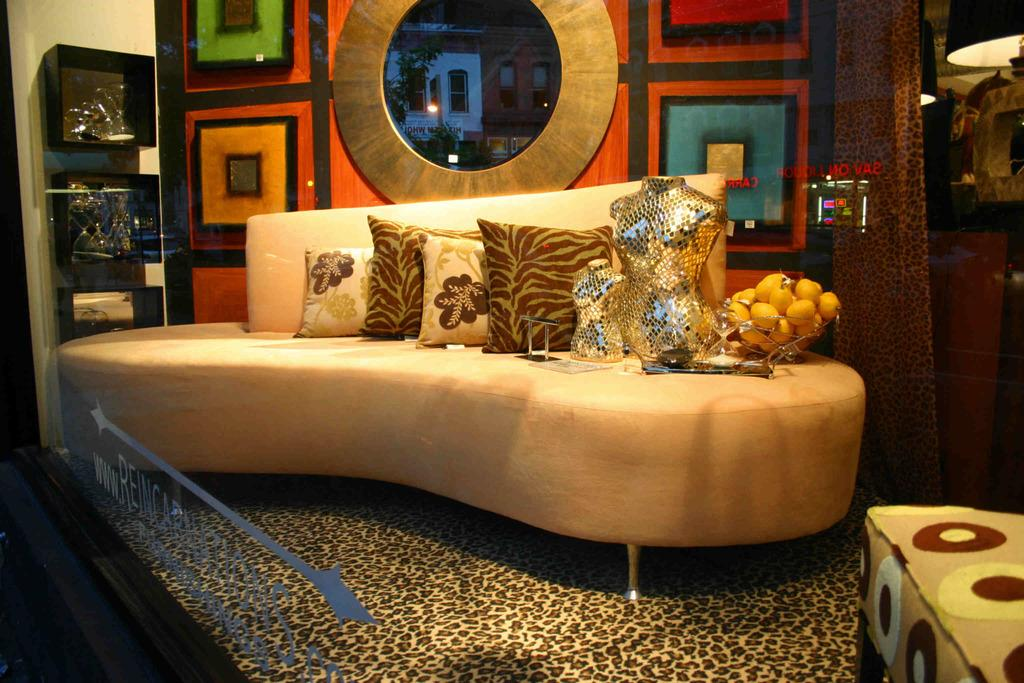What type of furniture is present in the image? There is a sofa in the image. What is placed on the sofa? The sofa has pillows on it and a bowl of fruits. How many mannequins are in the image? There are two mannequins in the image. What type of environment is depicted in the image? The image showcases a home environment. What can be seen in the background of the image? There are architecture patterns visible in the background. How does the sweater protect the mannequins from the earthquake in the image? There is no sweater or earthquake present in the image. What type of mist can be seen surrounding the mannequins in the image? There is no mist present in the image; it is a clear home environment. 